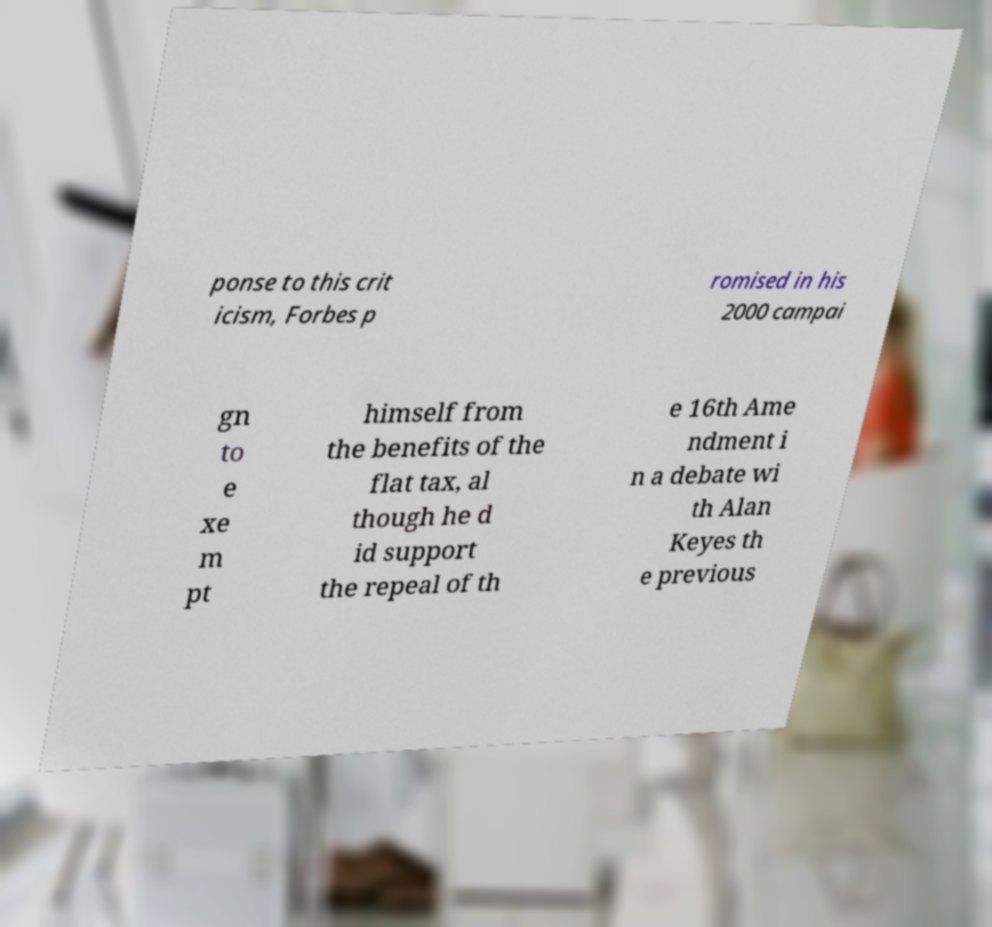What messages or text are displayed in this image? I need them in a readable, typed format. ponse to this crit icism, Forbes p romised in his 2000 campai gn to e xe m pt himself from the benefits of the flat tax, al though he d id support the repeal of th e 16th Ame ndment i n a debate wi th Alan Keyes th e previous 